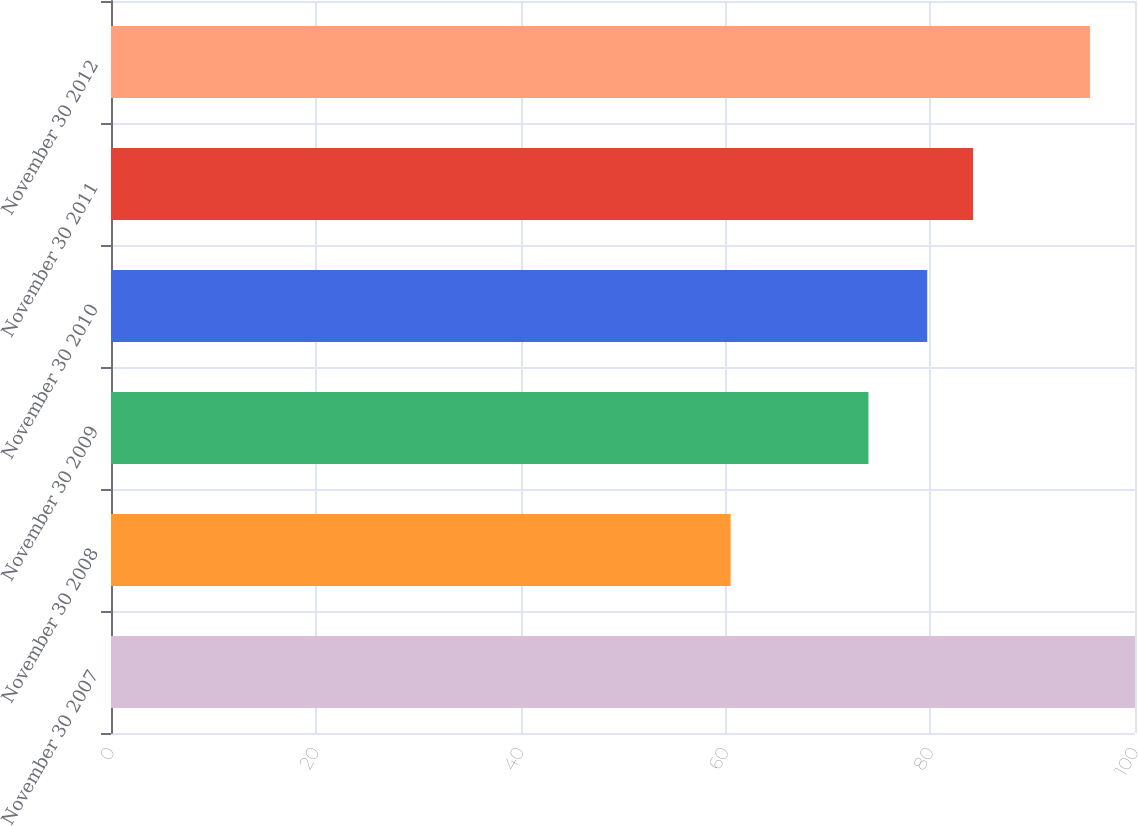<chart> <loc_0><loc_0><loc_500><loc_500><bar_chart><fcel>November 30 2007<fcel>November 30 2008<fcel>November 30 2009<fcel>November 30 2010<fcel>November 30 2011<fcel>November 30 2012<nl><fcel>100<fcel>60.51<fcel>73.97<fcel>79.71<fcel>84.19<fcel>95.61<nl></chart> 